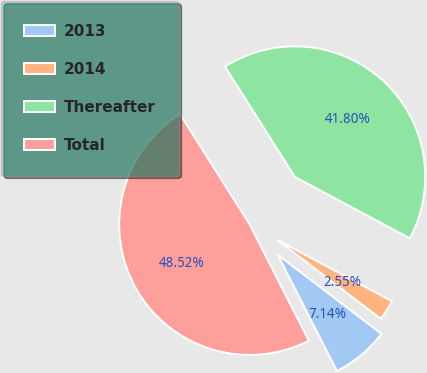<chart> <loc_0><loc_0><loc_500><loc_500><pie_chart><fcel>2013<fcel>2014<fcel>Thereafter<fcel>Total<nl><fcel>7.14%<fcel>2.55%<fcel>41.8%<fcel>48.52%<nl></chart> 